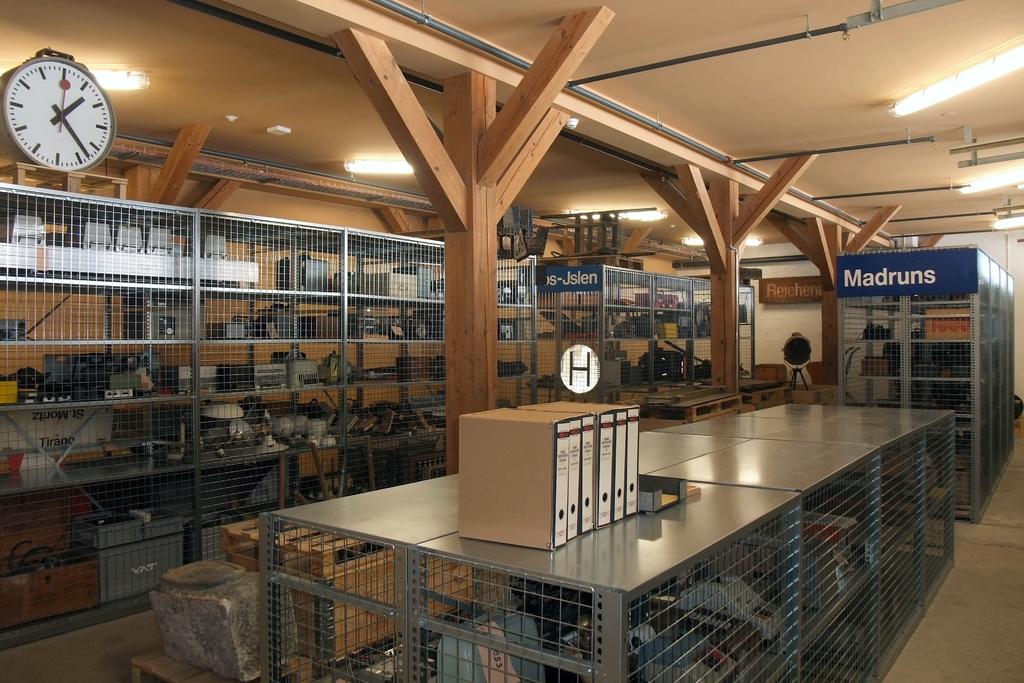What time is on the clock?
Offer a very short reply. 1:23. What is on the blue banner?
Offer a very short reply. Madruns. 